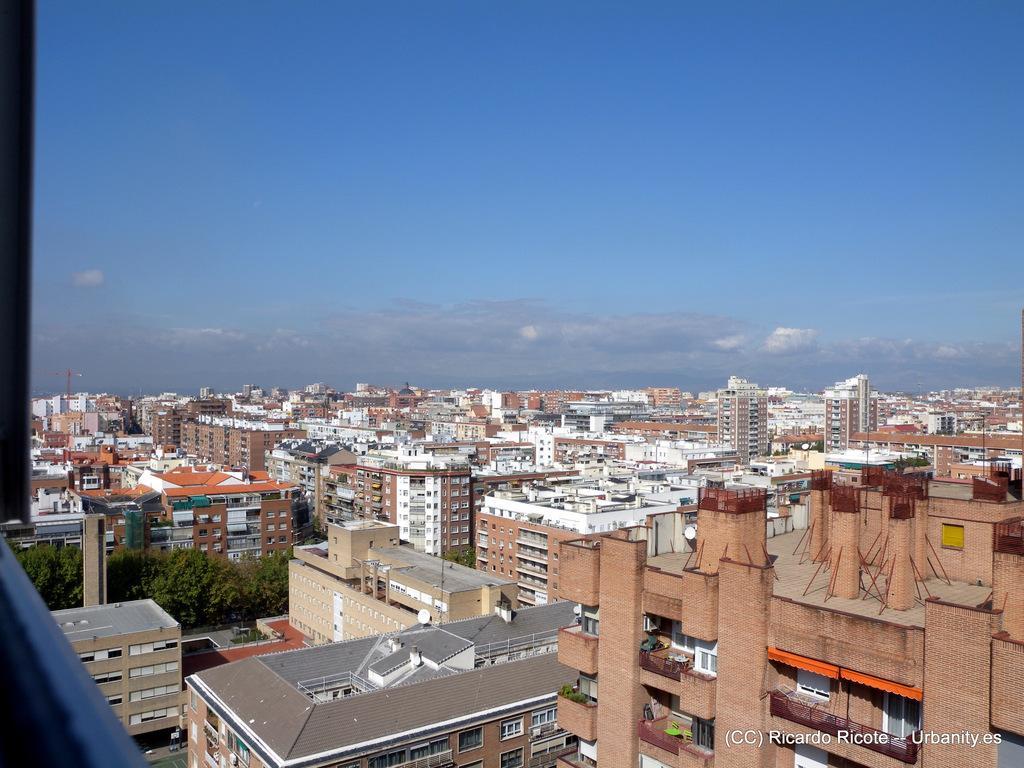Describe this image in one or two sentences. This image is taken outdoors. At the top of the image there is the sky with clouds. In the middle of the image there are many buildings, houses, walls, windows, balconies, railings and roofs. There are a few trees with green leaves, stems and branches. 